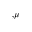<formula> <loc_0><loc_0><loc_500><loc_500>{ } _ { , \mu }</formula> 